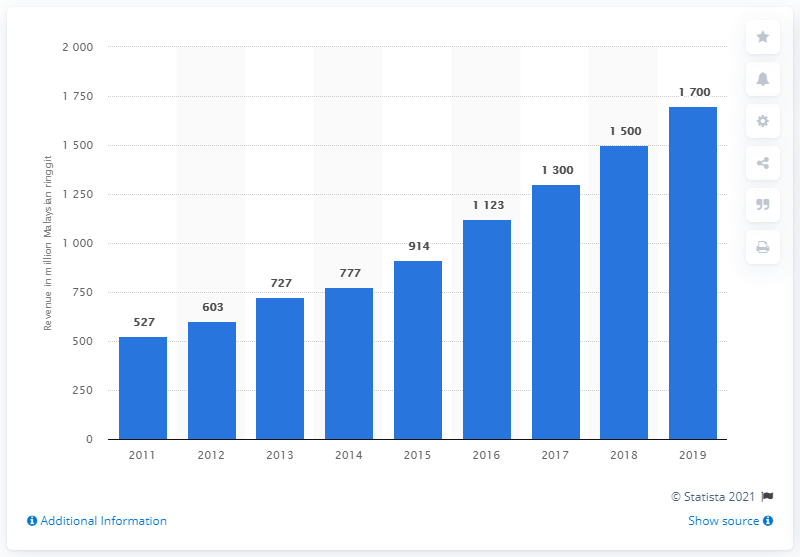Indicate a few pertinent items in this graphic. In 2019, the revenue generated from medical tourism in Malaysia was approximately 1,700. Revenue from medical tourism in Malaysia has increased by 1,700% since 2011. 